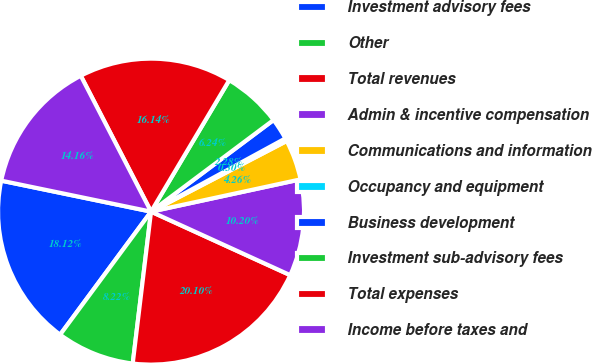<chart> <loc_0><loc_0><loc_500><loc_500><pie_chart><fcel>Investment advisory fees<fcel>Other<fcel>Total revenues<fcel>Admin & incentive compensation<fcel>Communications and information<fcel>Occupancy and equipment<fcel>Business development<fcel>Investment sub-advisory fees<fcel>Total expenses<fcel>Income before taxes and<nl><fcel>18.12%<fcel>8.22%<fcel>20.1%<fcel>10.2%<fcel>4.26%<fcel>0.3%<fcel>2.28%<fcel>6.24%<fcel>16.14%<fcel>14.16%<nl></chart> 